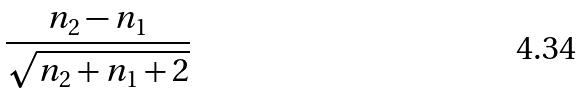<formula> <loc_0><loc_0><loc_500><loc_500>\frac { n _ { 2 } - n _ { 1 } } { \sqrt { n _ { 2 } + n _ { 1 } + 2 } }</formula> 